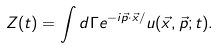Convert formula to latex. <formula><loc_0><loc_0><loc_500><loc_500>Z ( t ) = \int d \Gamma e ^ { - i \vec { p } \cdot \vec { x } / } u ( \vec { x } , \vec { p } ; t ) .</formula> 